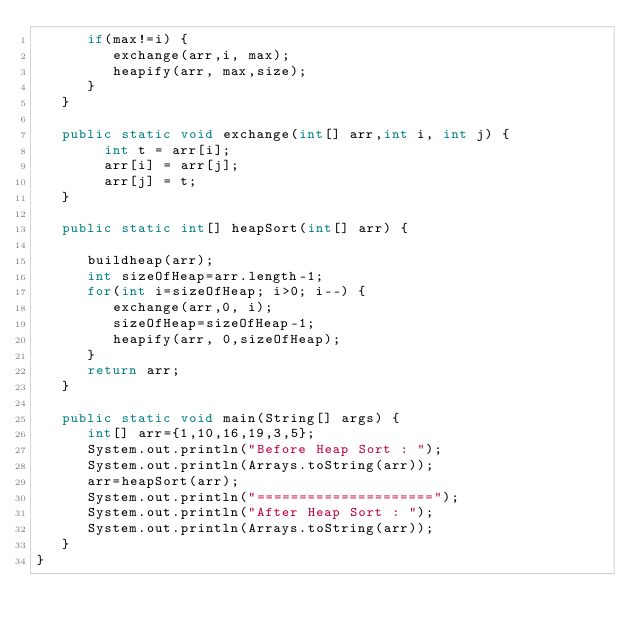<code> <loc_0><loc_0><loc_500><loc_500><_Java_>      if(max!=i) {
         exchange(arr,i, max);
         heapify(arr, max,size);
      }
   }
 
   public static void exchange(int[] arr,int i, int j) {
        int t = arr[i];
        arr[i] = arr[j];
        arr[j] = t; 
   }
 
   public static int[] heapSort(int[] arr) {
     
      buildheap(arr);
      int sizeOfHeap=arr.length-1;
      for(int i=sizeOfHeap; i>0; i--) {
         exchange(arr,0, i);
         sizeOfHeap=sizeOfHeap-1;
         heapify(arr, 0,sizeOfHeap);
      }
      return arr;
   }
 
   public static void main(String[] args) {
      int[] arr={1,10,16,19,3,5};
      System.out.println("Before Heap Sort : ");
      System.out.println(Arrays.toString(arr));
      arr=heapSort(arr);
      System.out.println("=====================");
      System.out.println("After Heap Sort : ");
      System.out.println(Arrays.toString(arr));
   }
}</code> 